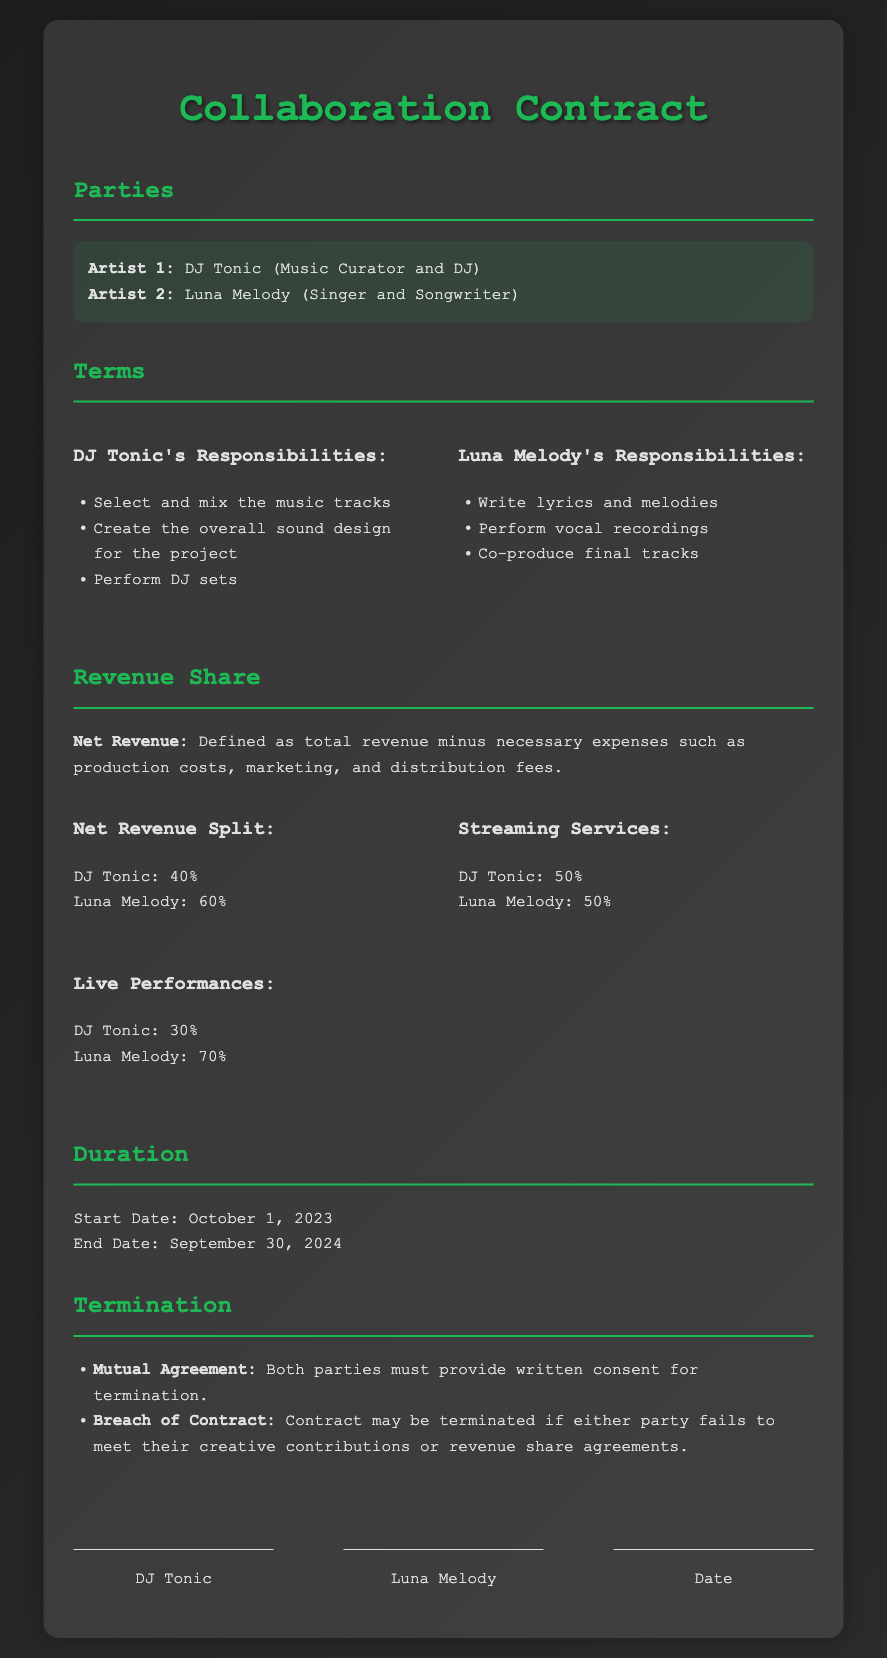what is the name of Artist 1? The document specifies that Artist 1 is DJ Tonic.
Answer: DJ Tonic what are DJ Tonic's responsibilities? The document lists DJ Tonic's responsibilities including selecting and mixing tracks and performing DJ sets.
Answer: Select and mix the music tracks, Create the overall sound design for the project, Perform DJ sets what percentage of net revenue does Luna Melody receive? According to the revenue share terms, Luna Melody receives 60% of the net revenue.
Answer: 60% what is the start date of the contract? The contract lists October 1, 2023 as the start date.
Answer: October 1, 2023 what happens if either party breaches the contract? The document states that the contract may be terminated if there is a breach of contract.
Answer: Contract may be terminated what is the revenue share split for streaming services? The document specifies that both parties share the streaming services revenue equally.
Answer: DJ Tonic: 50%, Luna Melody: 50% how long is the duration of the contract? The contract duration is specified from October 1, 2023 to September 30, 2024, which is one year.
Answer: One year which artist is responsible for writing lyrics? The document states that Luna Melody is responsible for writing lyrics and melodies.
Answer: Luna Melody what is the revenue share for live performances for DJ Tonic? According to the document, DJ Tonic receives 30% from live performances.
Answer: 30% 